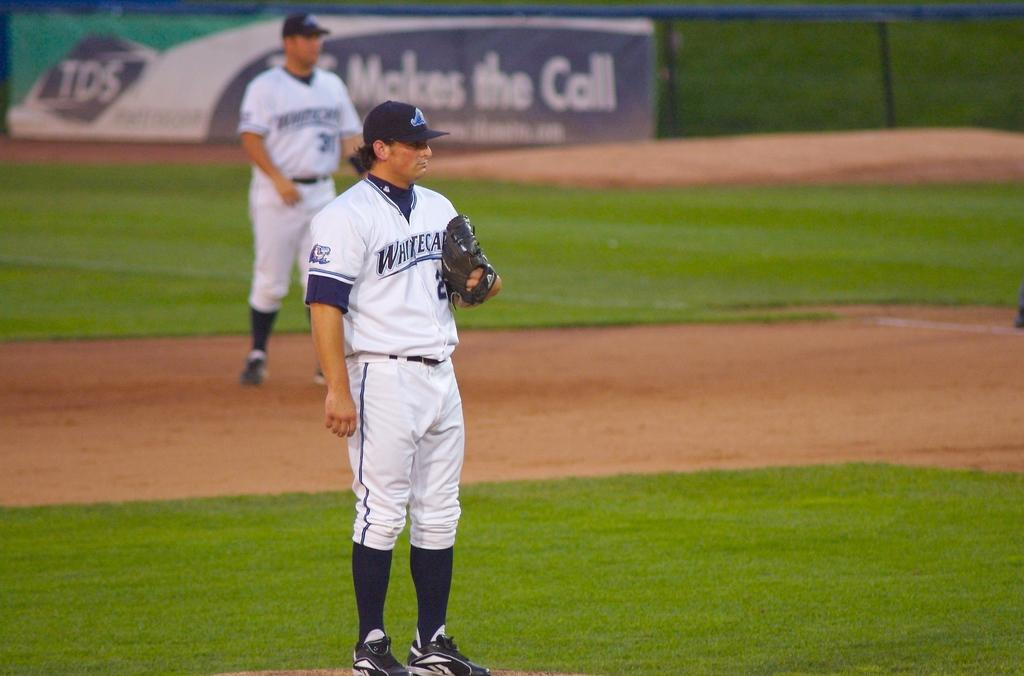<image>
Give a short and clear explanation of the subsequent image. Baseball player for the Whitecats getting ready to pitch. 